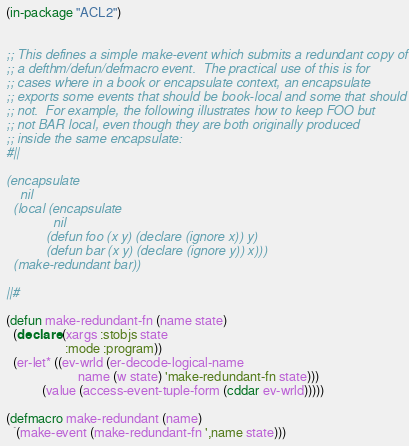<code> <loc_0><loc_0><loc_500><loc_500><_Lisp_>
(in-package "ACL2")


;; This defines a simple make-event which submits a redundant copy of
;; a defthm/defun/defmacro event.  The practical use of this is for
;; cases where in a book or encapsulate context, an encapsulate
;; exports some events that should be book-local and some that should
;; not.  For example, the following illustrates how to keep FOO but
;; not BAR local, even though they are both originally produced
;; inside the same encapsulate:
#||

(encapsulate
    nil
  (local (encapsulate
             nil
           (defun foo (x y) (declare (ignore x)) y)
           (defun bar (x y) (declare (ignore y)) x)))
  (make-redundant bar))

||#

(defun make-redundant-fn (name state)
  (declare (xargs :stobjs state
                  :mode :program))
  (er-let* ((ev-wrld (er-decode-logical-name
                      name (w state) 'make-redundant-fn state)))
           (value (access-event-tuple-form (cddar ev-wrld)))))

(defmacro make-redundant (name)
  `(make-event (make-redundant-fn ',name state)))


</code> 